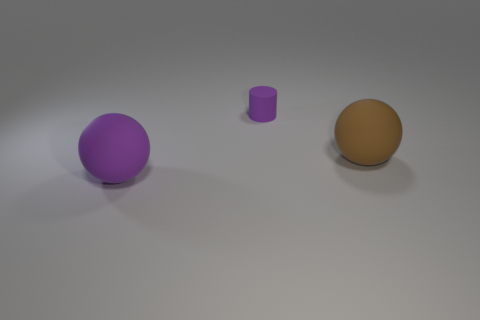What is the shape of the other object that is the same color as the small rubber thing?
Your answer should be compact. Sphere. There is a purple thing to the left of the small rubber thing; what is its size?
Make the answer very short. Large. There is a purple ball; is it the same size as the matte sphere that is right of the small rubber cylinder?
Make the answer very short. Yes. There is a large thing to the right of the purple matte object that is in front of the rubber cylinder; what color is it?
Offer a very short reply. Brown. How many other objects are the same color as the cylinder?
Ensure brevity in your answer.  1. What is the size of the purple sphere?
Your answer should be very brief. Large. Is the number of small rubber objects that are on the left side of the big purple sphere greater than the number of purple cylinders that are behind the tiny purple cylinder?
Provide a short and direct response. No. What number of big brown rubber balls are behind the large matte ball on the right side of the small cylinder?
Your answer should be compact. 0. There is a brown object in front of the small purple rubber object; does it have the same shape as the small purple rubber thing?
Offer a very short reply. No. There is a large purple object that is the same shape as the brown rubber object; what material is it?
Keep it short and to the point. Rubber. 